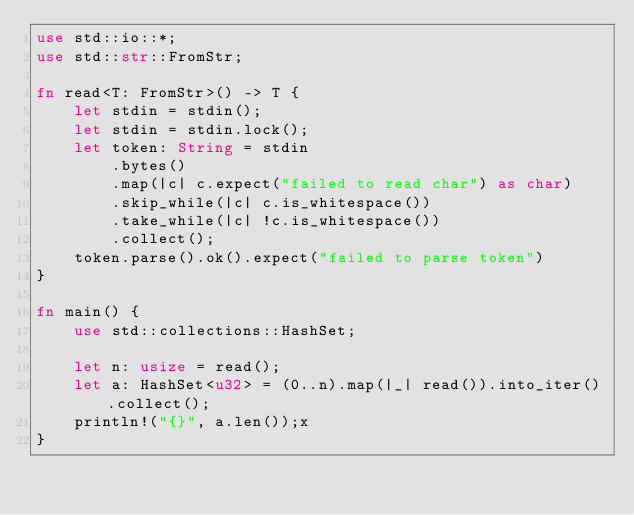<code> <loc_0><loc_0><loc_500><loc_500><_Rust_>use std::io::*;
use std::str::FromStr;

fn read<T: FromStr>() -> T {
    let stdin = stdin();
    let stdin = stdin.lock();
    let token: String = stdin
        .bytes()
        .map(|c| c.expect("failed to read char") as char)
        .skip_while(|c| c.is_whitespace())
        .take_while(|c| !c.is_whitespace())
        .collect();
    token.parse().ok().expect("failed to parse token")
}

fn main() {
    use std::collections::HashSet;

    let n: usize = read();
    let a: HashSet<u32> = (0..n).map(|_| read()).into_iter().collect();
    println!("{}", a.len());x
}</code> 